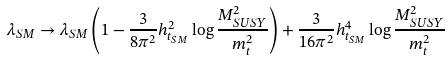Convert formula to latex. <formula><loc_0><loc_0><loc_500><loc_500>\lambda _ { S M } \to \lambda _ { S M } \left ( 1 - \frac { 3 } { 8 \pi ^ { 2 } } h _ { t _ { S M } } ^ { 2 } \log { \frac { M _ { S U S Y } ^ { 2 } } { m _ { t } ^ { 2 } } } \right ) + \frac { 3 } { 1 6 \pi ^ { 2 } } h _ { t _ { S M } } ^ { 4 } \log { \frac { M _ { S U S Y } ^ { 2 } } { m _ { t } ^ { 2 } } }</formula> 